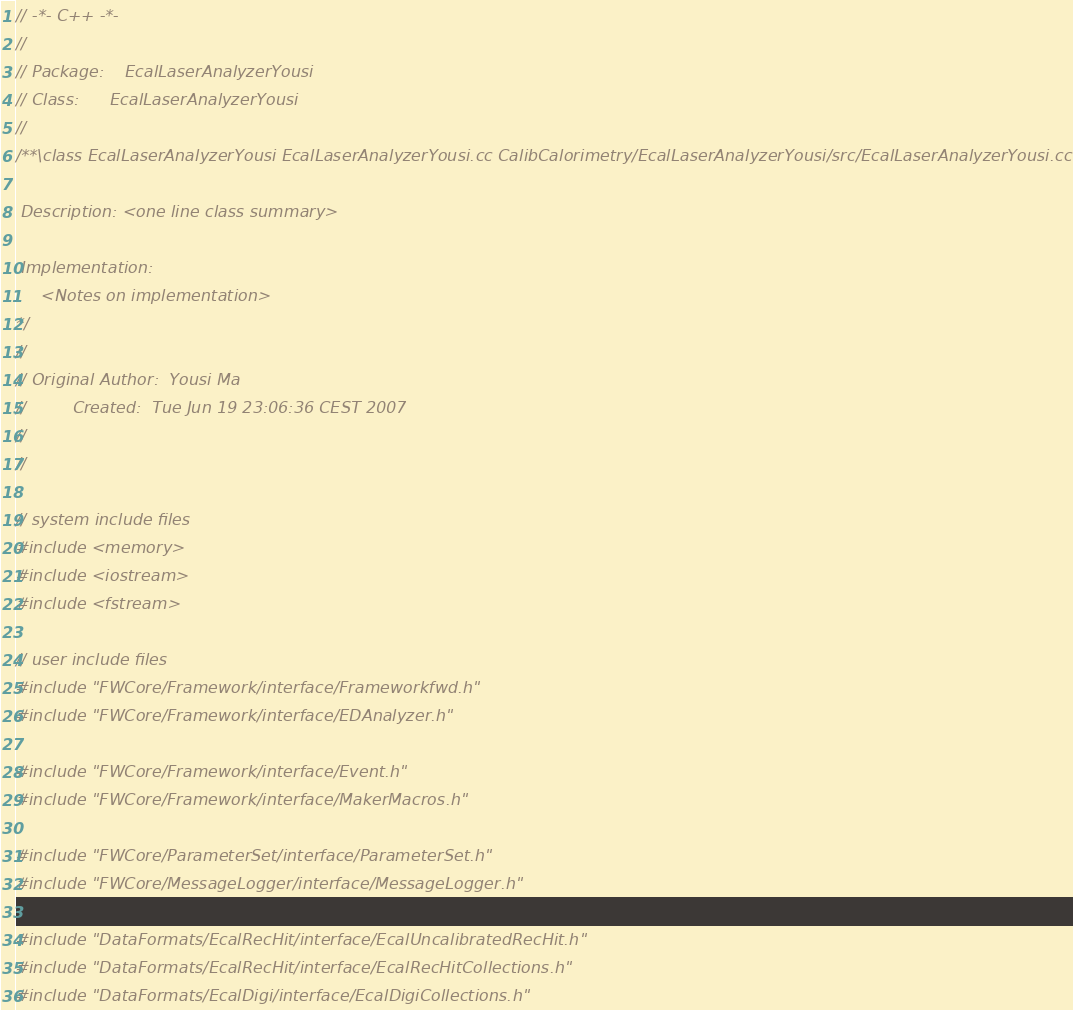<code> <loc_0><loc_0><loc_500><loc_500><_C++_>// -*- C++ -*-
//
// Package:    EcalLaserAnalyzerYousi
// Class:      EcalLaserAnalyzerYousi
//
/**\class EcalLaserAnalyzerYousi EcalLaserAnalyzerYousi.cc CalibCalorimetry/EcalLaserAnalyzerYousi/src/EcalLaserAnalyzerYousi.cc

 Description: <one line class summary>

 Implementation:
     <Notes on implementation>
*/
//
// Original Author:  Yousi Ma
//         Created:  Tue Jun 19 23:06:36 CEST 2007
//
//

// system include files
#include <memory>
#include <iostream>
#include <fstream>

// user include files
#include "FWCore/Framework/interface/Frameworkfwd.h"
#include "FWCore/Framework/interface/EDAnalyzer.h"

#include "FWCore/Framework/interface/Event.h"
#include "FWCore/Framework/interface/MakerMacros.h"

#include "FWCore/ParameterSet/interface/ParameterSet.h"
#include "FWCore/MessageLogger/interface/MessageLogger.h"

#include "DataFormats/EcalRecHit/interface/EcalUncalibratedRecHit.h"
#include "DataFormats/EcalRecHit/interface/EcalRecHitCollections.h"
#include "DataFormats/EcalDigi/interface/EcalDigiCollections.h"</code> 